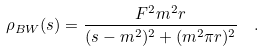Convert formula to latex. <formula><loc_0><loc_0><loc_500><loc_500>\rho _ { B W } ( s ) = { \frac { F ^ { 2 } m ^ { 2 } r } { ( s - m ^ { 2 } ) ^ { 2 } + ( m ^ { 2 } \pi r ) ^ { 2 } } } \ \ .</formula> 